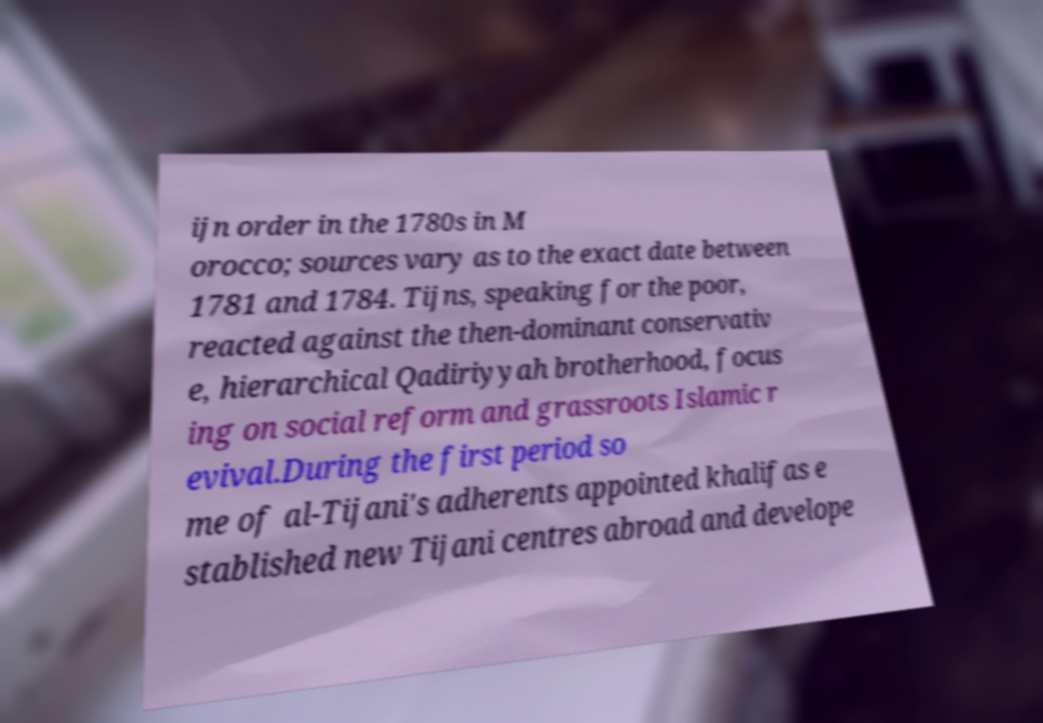Please read and relay the text visible in this image. What does it say? ijn order in the 1780s in M orocco; sources vary as to the exact date between 1781 and 1784. Tijns, speaking for the poor, reacted against the then-dominant conservativ e, hierarchical Qadiriyyah brotherhood, focus ing on social reform and grassroots Islamic r evival.During the first period so me of al-Tijani's adherents appointed khalifas e stablished new Tijani centres abroad and develope 